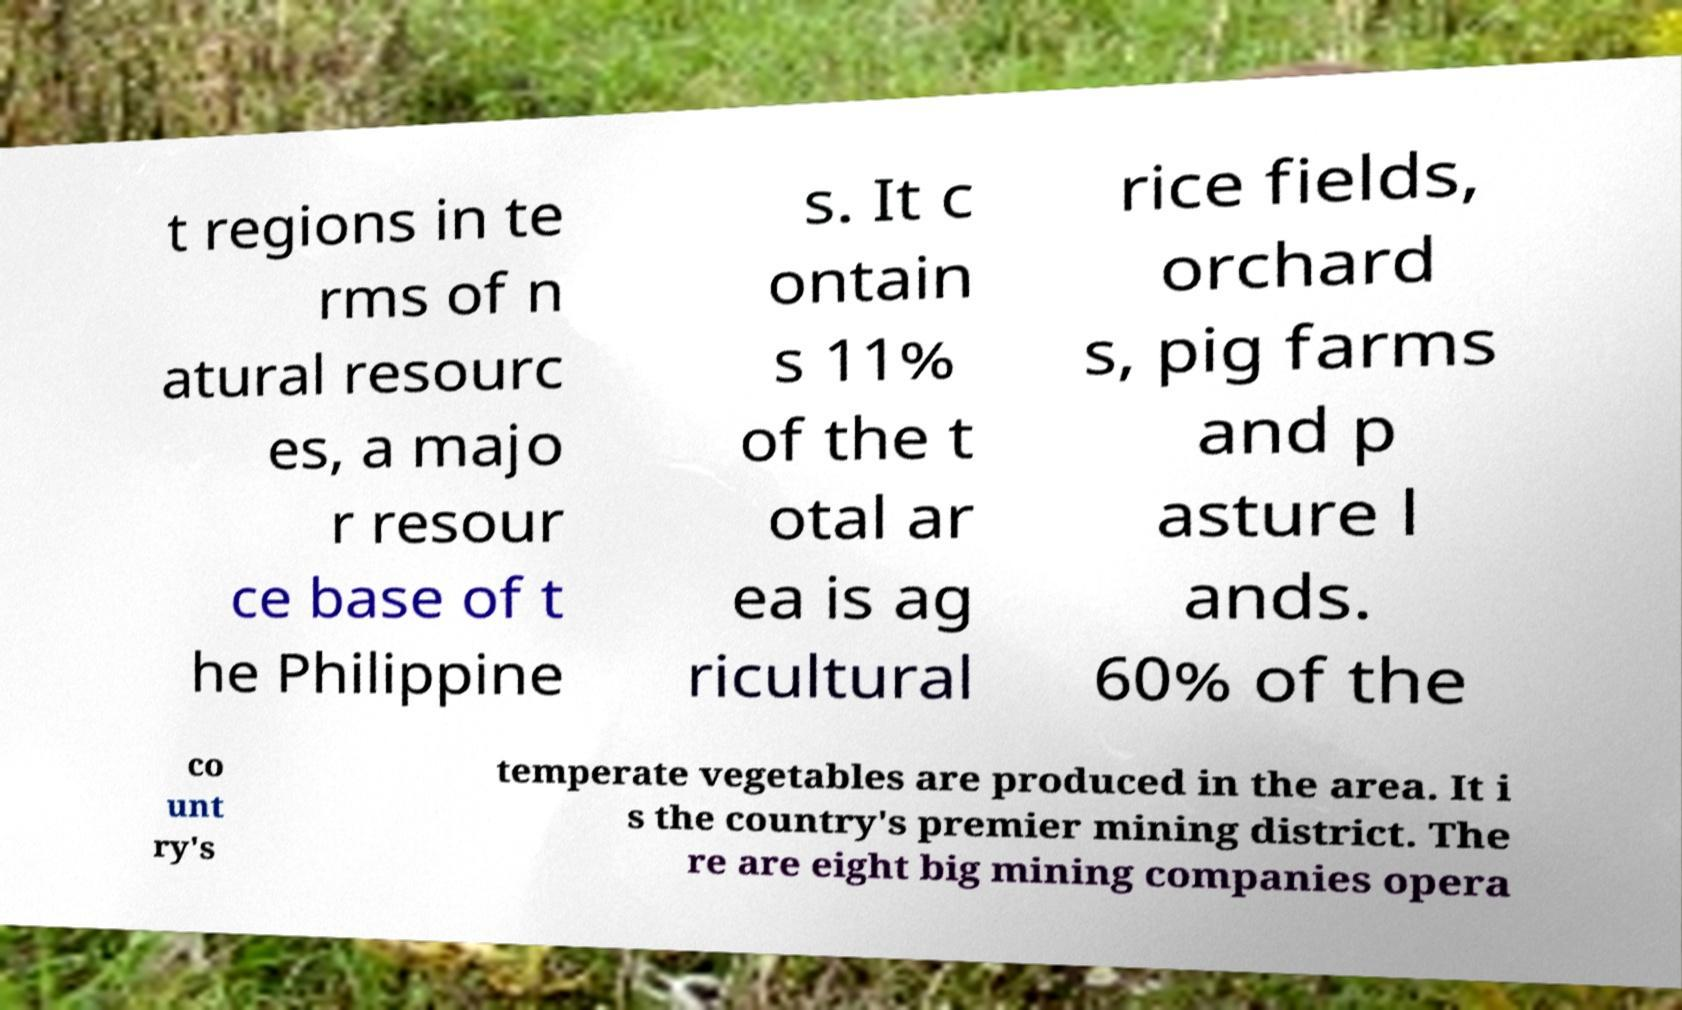Could you extract and type out the text from this image? t regions in te rms of n atural resourc es, a majo r resour ce base of t he Philippine s. It c ontain s 11% of the t otal ar ea is ag ricultural rice fields, orchard s, pig farms and p asture l ands. 60% of the co unt ry's temperate vegetables are produced in the area. It i s the country's premier mining district. The re are eight big mining companies opera 